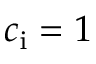<formula> <loc_0><loc_0><loc_500><loc_500>c _ { i } = 1</formula> 